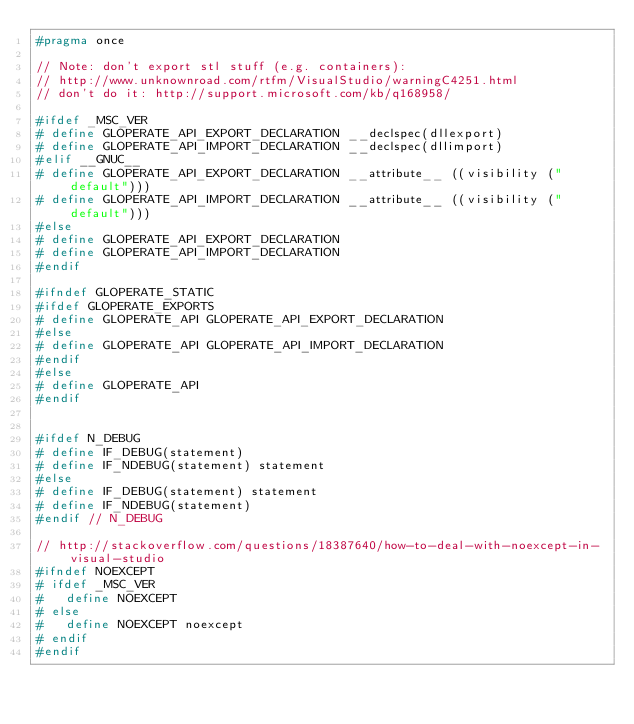<code> <loc_0><loc_0><loc_500><loc_500><_C_>#pragma once

// Note: don't export stl stuff (e.g. containers):
// http://www.unknownroad.com/rtfm/VisualStudio/warningC4251.html
// don't do it: http://support.microsoft.com/kb/q168958/

#ifdef _MSC_VER
#	define GLOPERATE_API_EXPORT_DECLARATION __declspec(dllexport)
#	define GLOPERATE_API_IMPORT_DECLARATION __declspec(dllimport)
#elif __GNUC__
#	define GLOPERATE_API_EXPORT_DECLARATION __attribute__ ((visibility ("default")))
#	define GLOPERATE_API_IMPORT_DECLARATION __attribute__ ((visibility ("default")))
#else
#	define GLOPERATE_API_EXPORT_DECLARATION
#	define GLOPERATE_API_IMPORT_DECLARATION
#endif

#ifndef GLOPERATE_STATIC
#ifdef GLOPERATE_EXPORTS
#	define GLOPERATE_API GLOPERATE_API_EXPORT_DECLARATION
#else
#	define GLOPERATE_API GLOPERATE_API_IMPORT_DECLARATION
#endif
#else
#	define GLOPERATE_API
#endif


#ifdef N_DEBUG
#	define IF_DEBUG(statement)
#	define IF_NDEBUG(statement) statement
#else
#	define IF_DEBUG(statement) statement
#	define IF_NDEBUG(statement)
#endif // N_DEBUG

// http://stackoverflow.com/questions/18387640/how-to-deal-with-noexcept-in-visual-studio
#ifndef NOEXCEPT
#	ifdef _MSC_VER
#		define NOEXCEPT
#	else
#		define NOEXCEPT noexcept
#	endif
#endif
</code> 